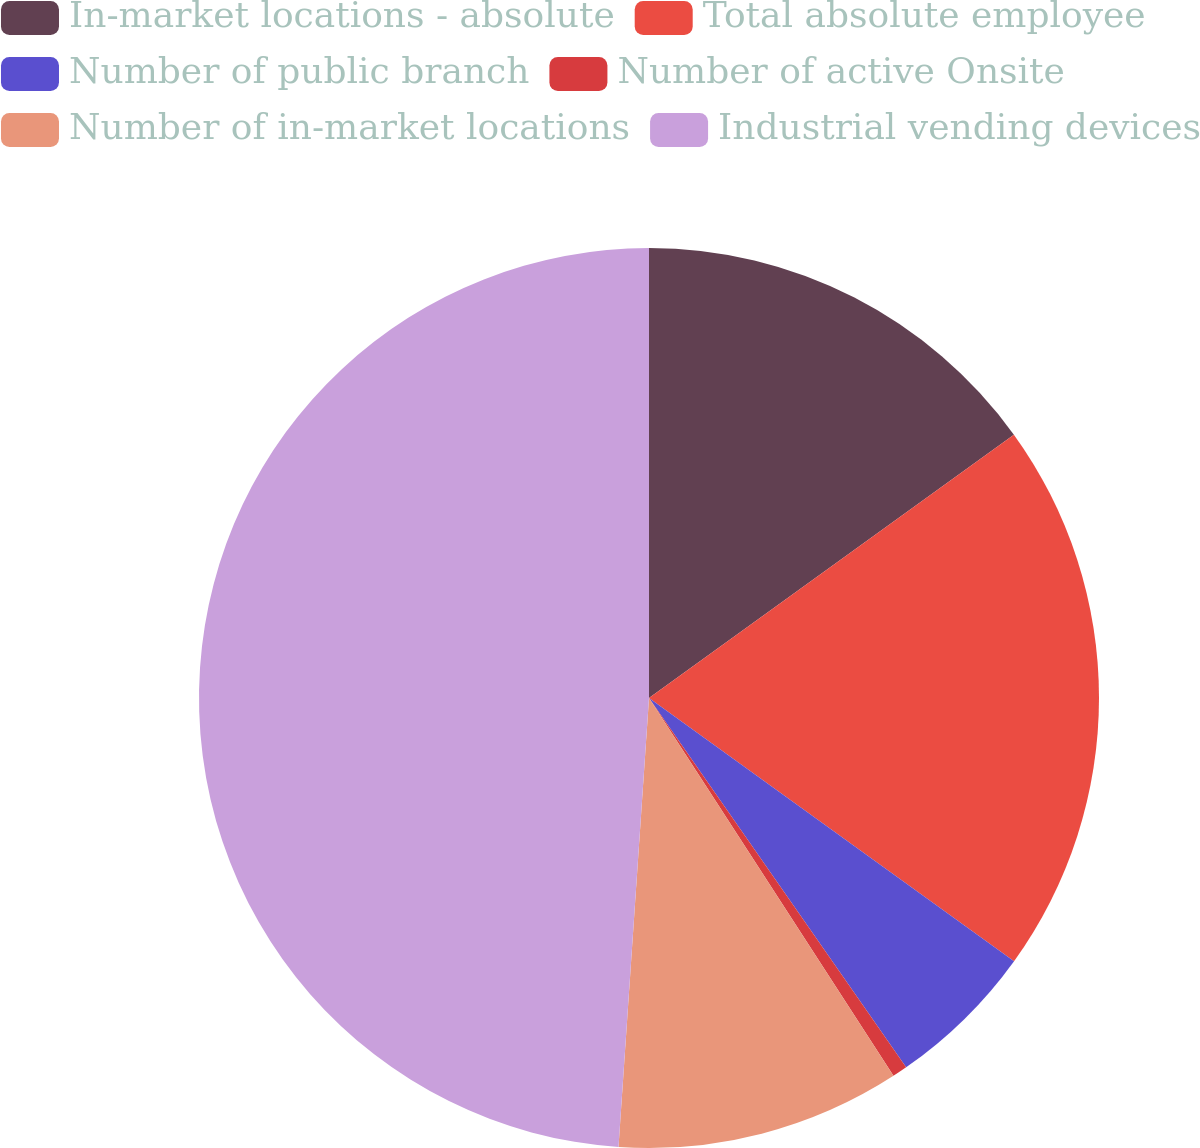Convert chart to OTSL. <chart><loc_0><loc_0><loc_500><loc_500><pie_chart><fcel>In-market locations - absolute<fcel>Total absolute employee<fcel>Number of public branch<fcel>Number of active Onsite<fcel>Number of in-market locations<fcel>Industrial vending devices<nl><fcel>15.05%<fcel>19.89%<fcel>5.38%<fcel>0.54%<fcel>10.22%<fcel>48.92%<nl></chart> 